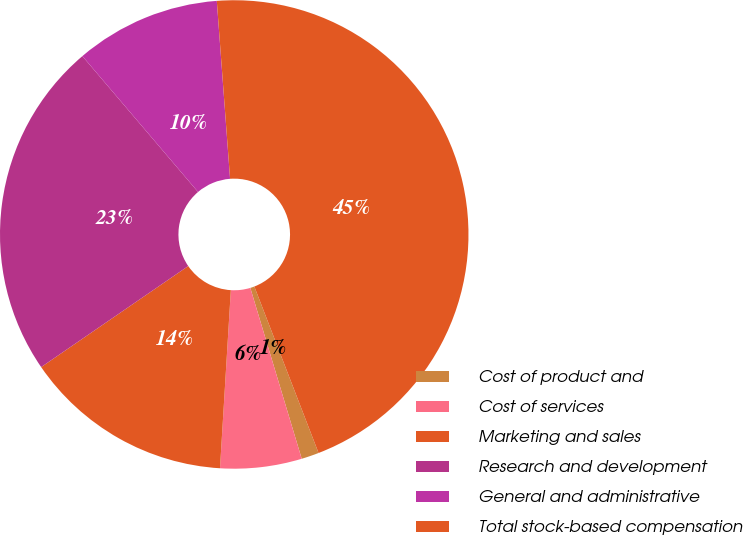Convert chart. <chart><loc_0><loc_0><loc_500><loc_500><pie_chart><fcel>Cost of product and<fcel>Cost of services<fcel>Marketing and sales<fcel>Research and development<fcel>General and administrative<fcel>Total stock-based compensation<nl><fcel>1.21%<fcel>5.62%<fcel>14.45%<fcel>23.35%<fcel>10.04%<fcel>45.32%<nl></chart> 